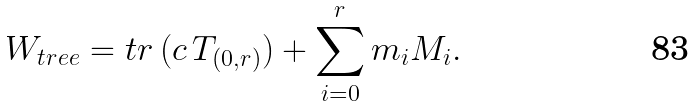Convert formula to latex. <formula><loc_0><loc_0><loc_500><loc_500>W _ { t r e e } = t r \, ( c \, T _ { ( 0 , r ) } ) + \sum _ { i = 0 } ^ { r } m _ { i } M _ { i } .</formula> 